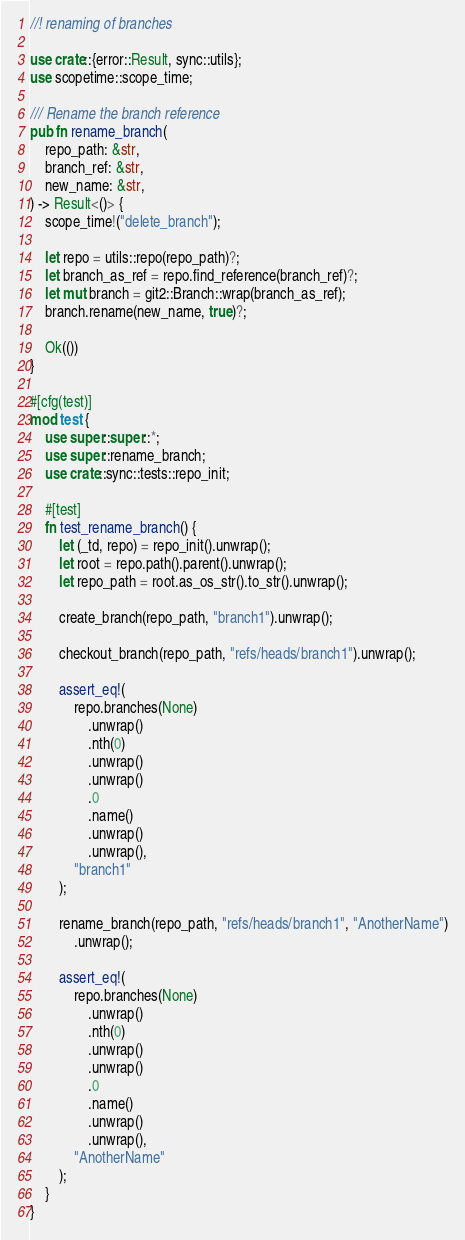<code> <loc_0><loc_0><loc_500><loc_500><_Rust_>//! renaming of branches

use crate::{error::Result, sync::utils};
use scopetime::scope_time;

/// Rename the branch reference
pub fn rename_branch(
	repo_path: &str,
	branch_ref: &str,
	new_name: &str,
) -> Result<()> {
	scope_time!("delete_branch");

	let repo = utils::repo(repo_path)?;
	let branch_as_ref = repo.find_reference(branch_ref)?;
	let mut branch = git2::Branch::wrap(branch_as_ref);
	branch.rename(new_name, true)?;

	Ok(())
}

#[cfg(test)]
mod test {
	use super::super::*;
	use super::rename_branch;
	use crate::sync::tests::repo_init;

	#[test]
	fn test_rename_branch() {
		let (_td, repo) = repo_init().unwrap();
		let root = repo.path().parent().unwrap();
		let repo_path = root.as_os_str().to_str().unwrap();

		create_branch(repo_path, "branch1").unwrap();

		checkout_branch(repo_path, "refs/heads/branch1").unwrap();

		assert_eq!(
			repo.branches(None)
				.unwrap()
				.nth(0)
				.unwrap()
				.unwrap()
				.0
				.name()
				.unwrap()
				.unwrap(),
			"branch1"
		);

		rename_branch(repo_path, "refs/heads/branch1", "AnotherName")
			.unwrap();

		assert_eq!(
			repo.branches(None)
				.unwrap()
				.nth(0)
				.unwrap()
				.unwrap()
				.0
				.name()
				.unwrap()
				.unwrap(),
			"AnotherName"
		);
	}
}
</code> 